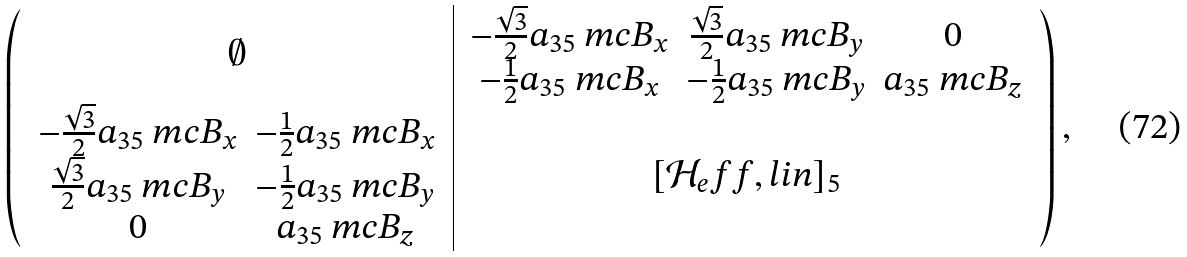<formula> <loc_0><loc_0><loc_500><loc_500>\left ( \begin{array} { c | c } \emptyset & \begin{array} { c c c } - \frac { \sqrt { 3 } } { 2 } a _ { 3 5 } \ m c B _ { x } & \frac { \sqrt { 3 } } { 2 } a _ { 3 5 } \ m c B _ { y } & 0 \\ - \frac { 1 } { 2 } a _ { 3 5 } \ m c B _ { x } & - \frac { 1 } { 2 } a _ { 3 5 } \ m c B _ { y } & a _ { 3 5 } \ m c B _ { z } \\ \end{array} \\ \begin{array} { c c } - \frac { \sqrt { 3 } } { 2 } a _ { 3 5 } \ m c B _ { x } & - \frac { 1 } { 2 } a _ { 3 5 } \ m c B _ { x } \\ \frac { \sqrt { 3 } } { 2 } a _ { 3 5 } \ m c B _ { y } & - \frac { 1 } { 2 } a _ { 3 5 } \ m c B _ { y } \\ 0 & a _ { 3 5 } \ m c B _ { z } \\ \end{array} & [ \mathcal { H } _ { e } f f , l i n ] _ { 5 } \\ \end{array} \right ) ,</formula> 